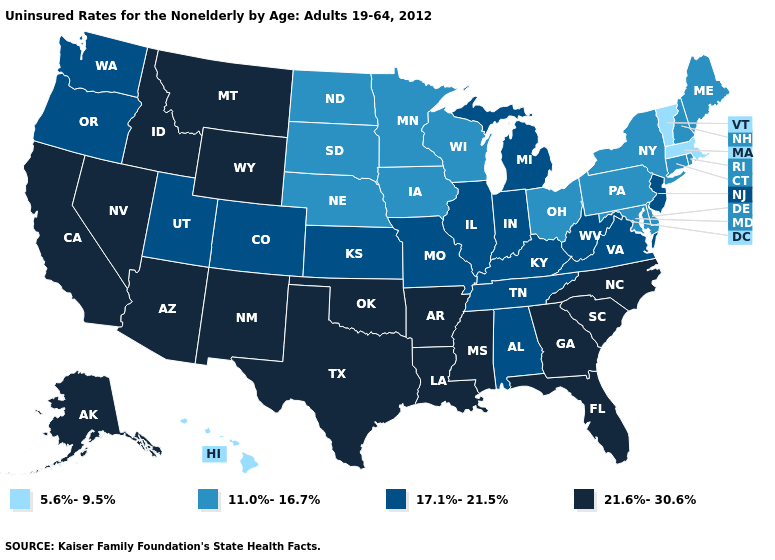Does New Hampshire have a lower value than Mississippi?
Concise answer only. Yes. Does Oklahoma have the highest value in the USA?
Be succinct. Yes. What is the lowest value in states that border Minnesota?
Be succinct. 11.0%-16.7%. Among the states that border Oregon , does Idaho have the lowest value?
Be succinct. No. Among the states that border Delaware , does New Jersey have the lowest value?
Answer briefly. No. Which states have the lowest value in the USA?
Quick response, please. Hawaii, Massachusetts, Vermont. What is the value of Indiana?
Be succinct. 17.1%-21.5%. How many symbols are there in the legend?
Short answer required. 4. Name the states that have a value in the range 21.6%-30.6%?
Concise answer only. Alaska, Arizona, Arkansas, California, Florida, Georgia, Idaho, Louisiana, Mississippi, Montana, Nevada, New Mexico, North Carolina, Oklahoma, South Carolina, Texas, Wyoming. Does the map have missing data?
Answer briefly. No. What is the value of Hawaii?
Answer briefly. 5.6%-9.5%. What is the value of Iowa?
Be succinct. 11.0%-16.7%. How many symbols are there in the legend?
Be succinct. 4. Name the states that have a value in the range 11.0%-16.7%?
Short answer required. Connecticut, Delaware, Iowa, Maine, Maryland, Minnesota, Nebraska, New Hampshire, New York, North Dakota, Ohio, Pennsylvania, Rhode Island, South Dakota, Wisconsin. Among the states that border Missouri , which have the lowest value?
Write a very short answer. Iowa, Nebraska. 